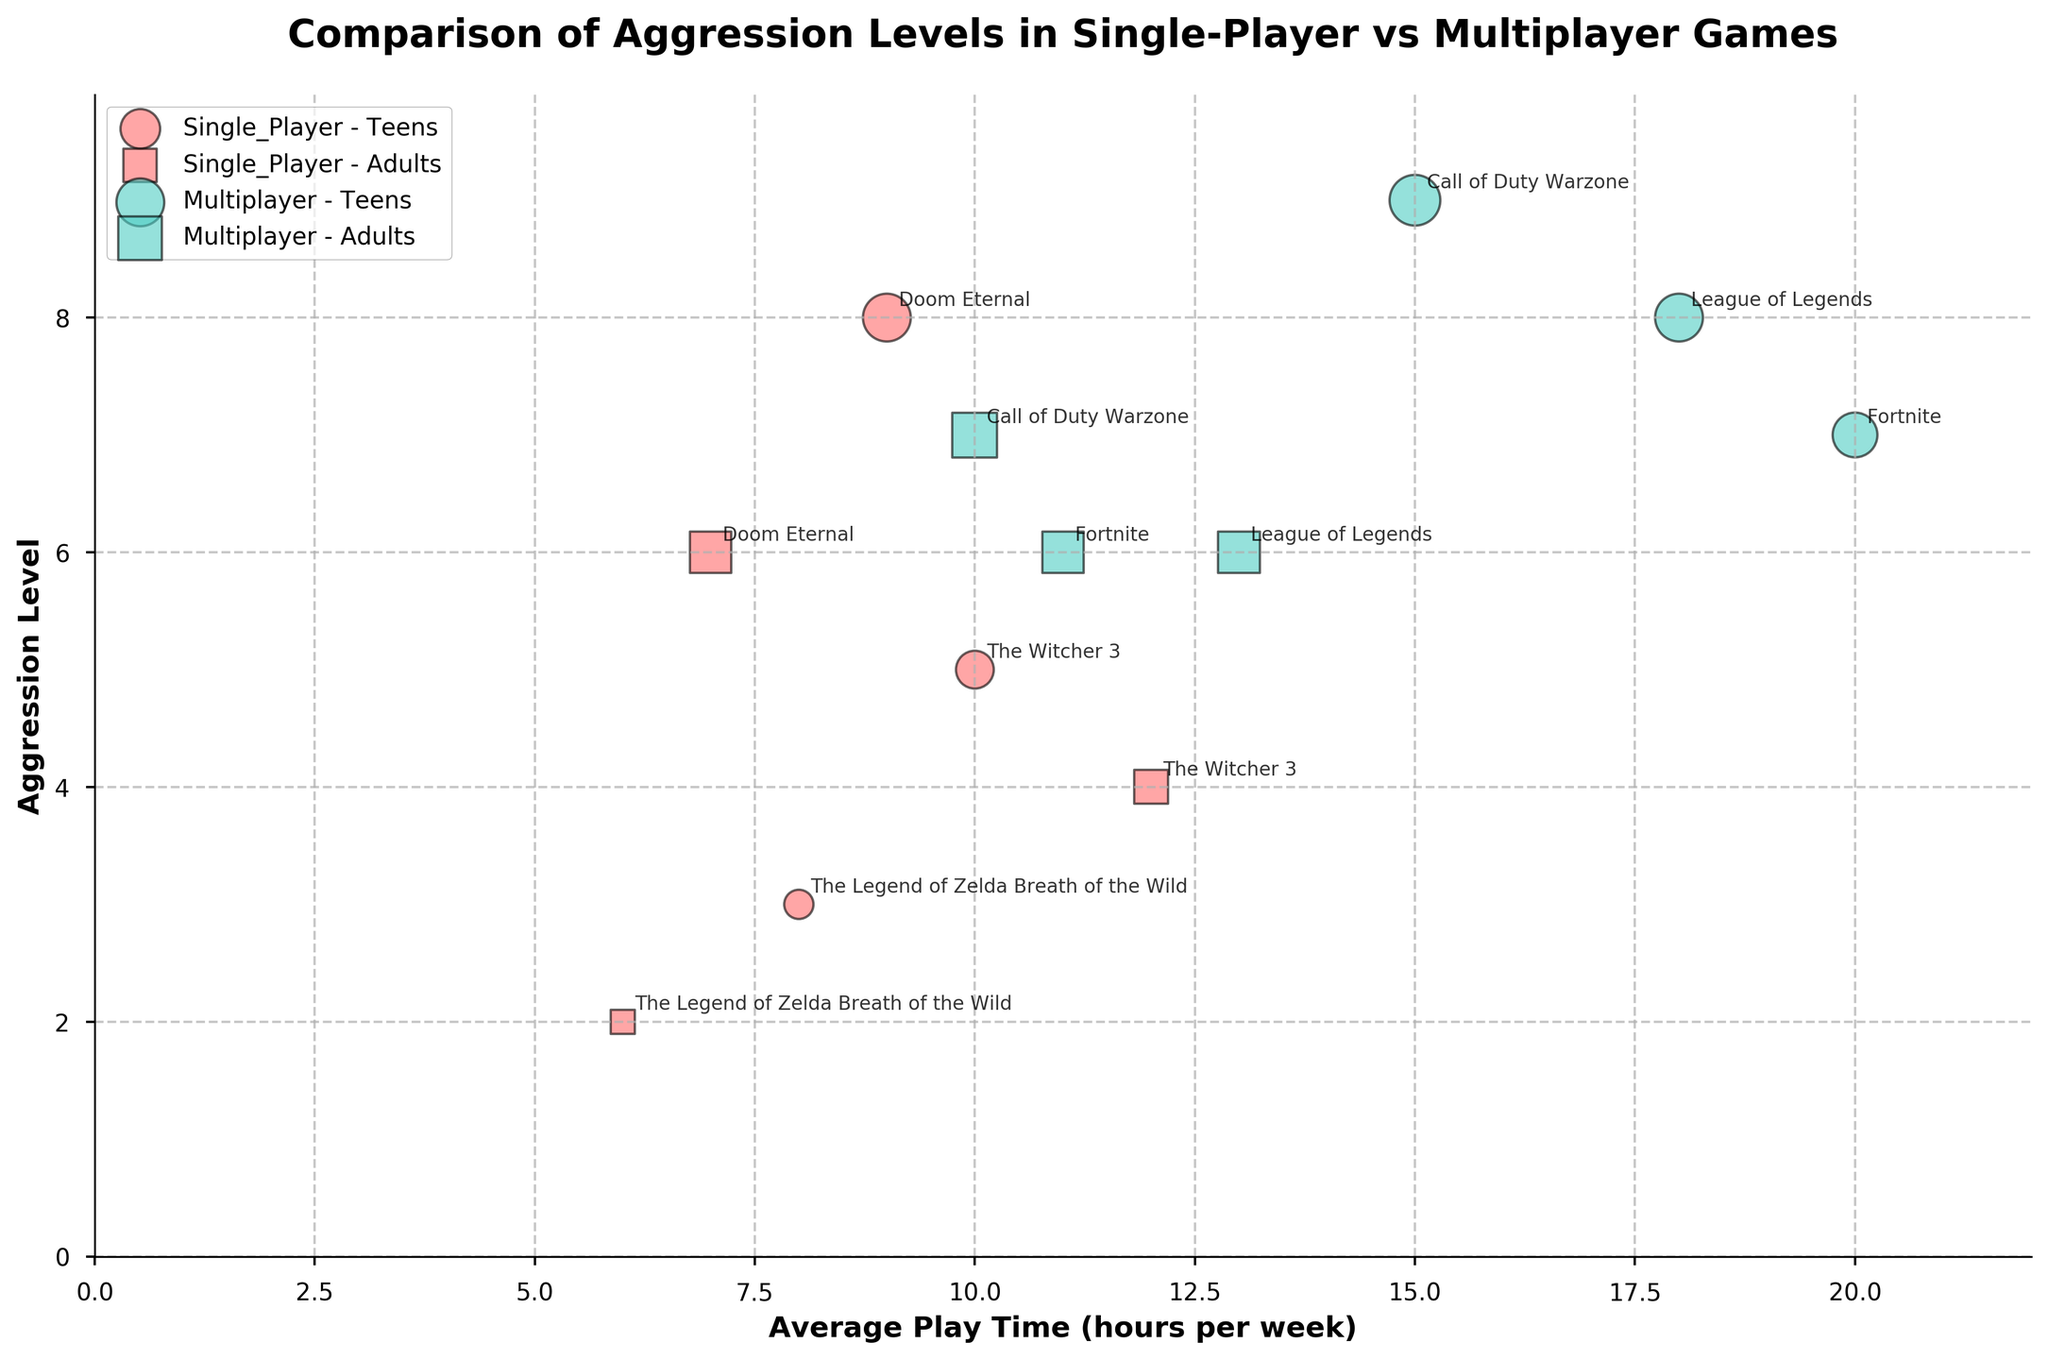What's the title of the figure? The title is located at the top of the figure. It summarizes the main insight of the visual representation.
Answer: Comparison of Aggression Levels in Single-Player vs Multiplayer Games How many games are represented in the figure? By looking at the labels and bubbles in the chart, each game is annotated with its title, indicating individual data points. Count these titles to get the number of games. There are 6 distinct game titles mentioned in the data.
Answer: 6 Which game has the highest aggression level among teens? Look for the most elevated bubble position on the y-axis (Aggression Level) for the "Teens" group in both game types. Check the labels to identify the game.
Answer: Call of Duty Warzone What is the average aggression level for adults playing multiplayer games? Locate all data points for adults in the "Multiplayer" game category, sum their aggression levels, and divide by the number of data points. The aggression levels are 7, 6, and 6. Average = (7+6+6) / 3 = 19 / 3 = 6.33.
Answer: 6.33 Compare the aggression levels between single-player and multiplayer games for teens playing for 15 hours per week. Which game has higher aggression? Identify the data points representing teens playing 15 hours per week in both game types. Look at the y-axis value. Call of Duty Warzone (Multiplayer) has a higher aggression level of 9 compared to any Single-Player game.
Answer: Multiplayer (Call of Duty Warzone) What is the total aggression level for adults playing single-player games? Identify and sum the y-axis positions (Aggression Level) of data points for adults in "Single_Player" game type. Values are 4, 2, and 6. Total = 4 + 2 + 6 = 12.
Answer: 12 Which age group has higher aggression levels when playing Doom Eternal? Check the y-axis values for "Doom Eternal" for both teens and adults. Teens have an aggression level of 8, while adults have 6. Teens have a higher level.
Answer: Teens What is the range of average playtime for multiplayer games? Identify the minimum and maximum x-axis values (Average Play Time) for "Multiplayer" games and calculate their range. Minimum is 10, and maximum is 20. Range = 20 - 10 = 10.
Answer: 10 Which game has the lowest aggression level among all games? Locate the lowest positioned bubble on the y-axis. Check the labels to identify it. "The Legend of Zelda: Breath of the Wild" (Adults) has the lowest aggression level of 2.
Answer: The Legend of Zelda: Breath of the Wild How do the aggression levels of single-player games compare with multiplayer games at 10 hours of average playtime for adults? Look at the bubbles marked for 10 hours of playtime for adults in both game categories. Compare their y-axis values (Aggression Level). Multiplayer (Call of Duty Warzone) has an aggression level of 7, while Single_Player (The Witcher 3) has an aggression level of 4. Multiplayer has a higher level.
Answer: Multiplayer (Call of Duty Warzone) 